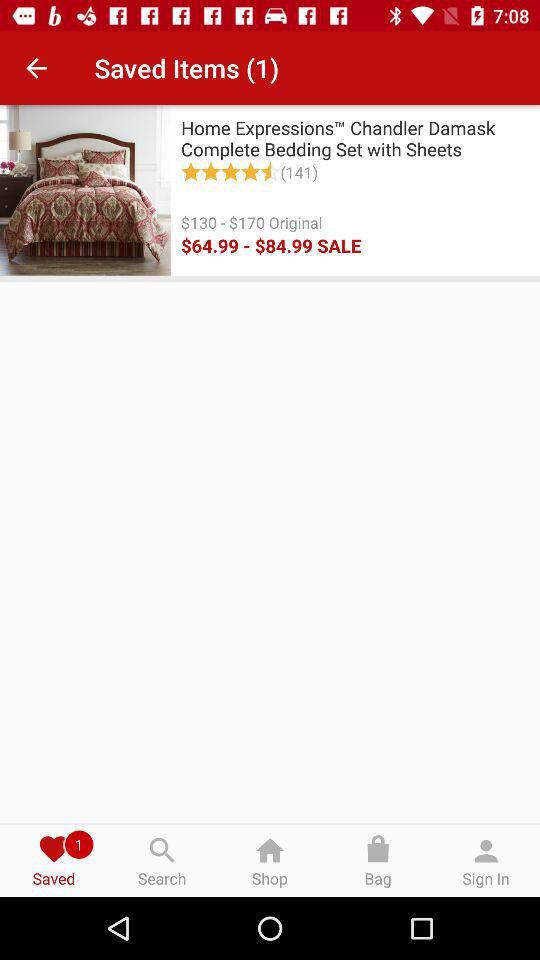What is the name of the product? The name of the product is "Home Expressions Chandler Damask Complete Bedding Set with Sheets". 